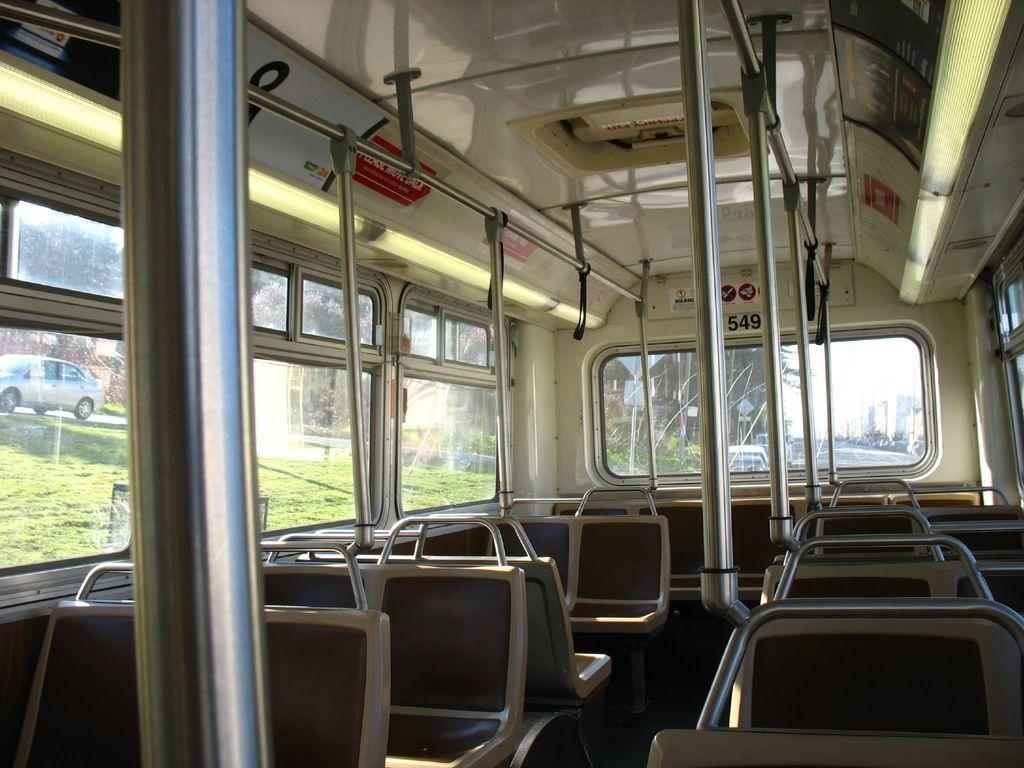Please provide a concise description of this image. It is an inside view of the vehicle. At the bottom, we can see seats, rods. In the middle of the image, we can see glass windows. Top of the image, there is a roof, stickers, signboards. Through the glass window, we can see the outside view. Here there is a gross, vehicle, road, poles, boards, trees. 